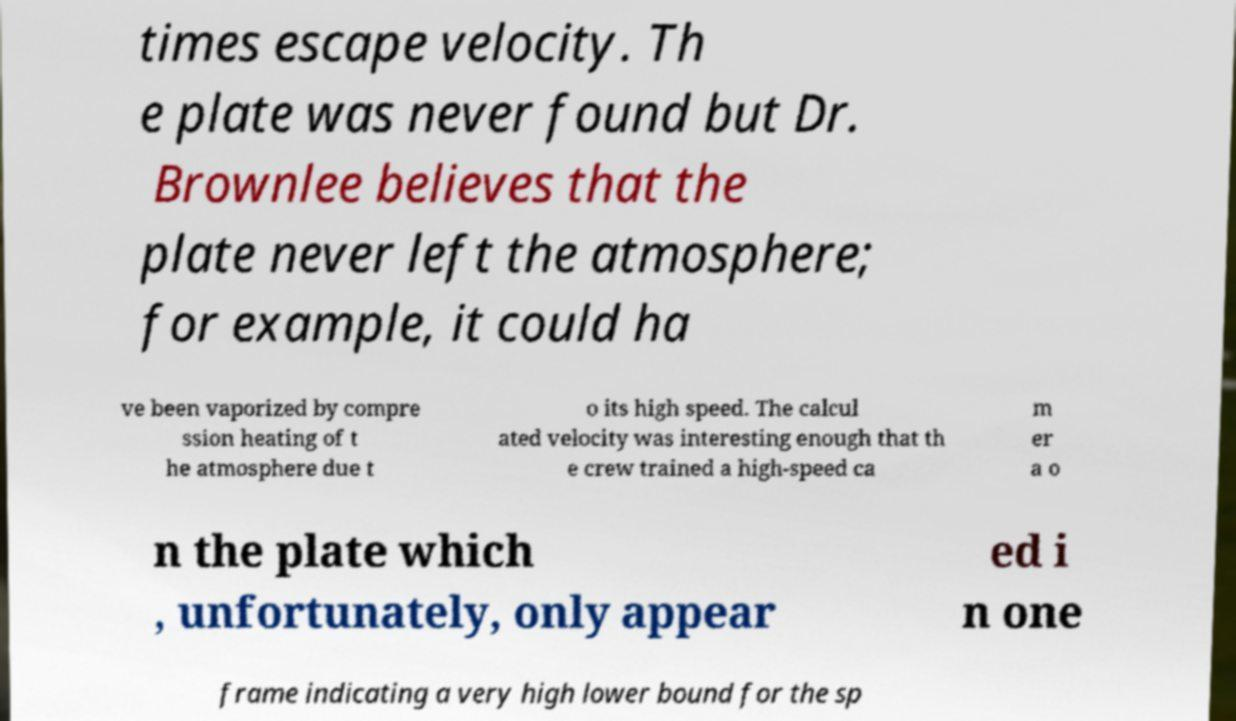Please identify and transcribe the text found in this image. times escape velocity. Th e plate was never found but Dr. Brownlee believes that the plate never left the atmosphere; for example, it could ha ve been vaporized by compre ssion heating of t he atmosphere due t o its high speed. The calcul ated velocity was interesting enough that th e crew trained a high-speed ca m er a o n the plate which , unfortunately, only appear ed i n one frame indicating a very high lower bound for the sp 